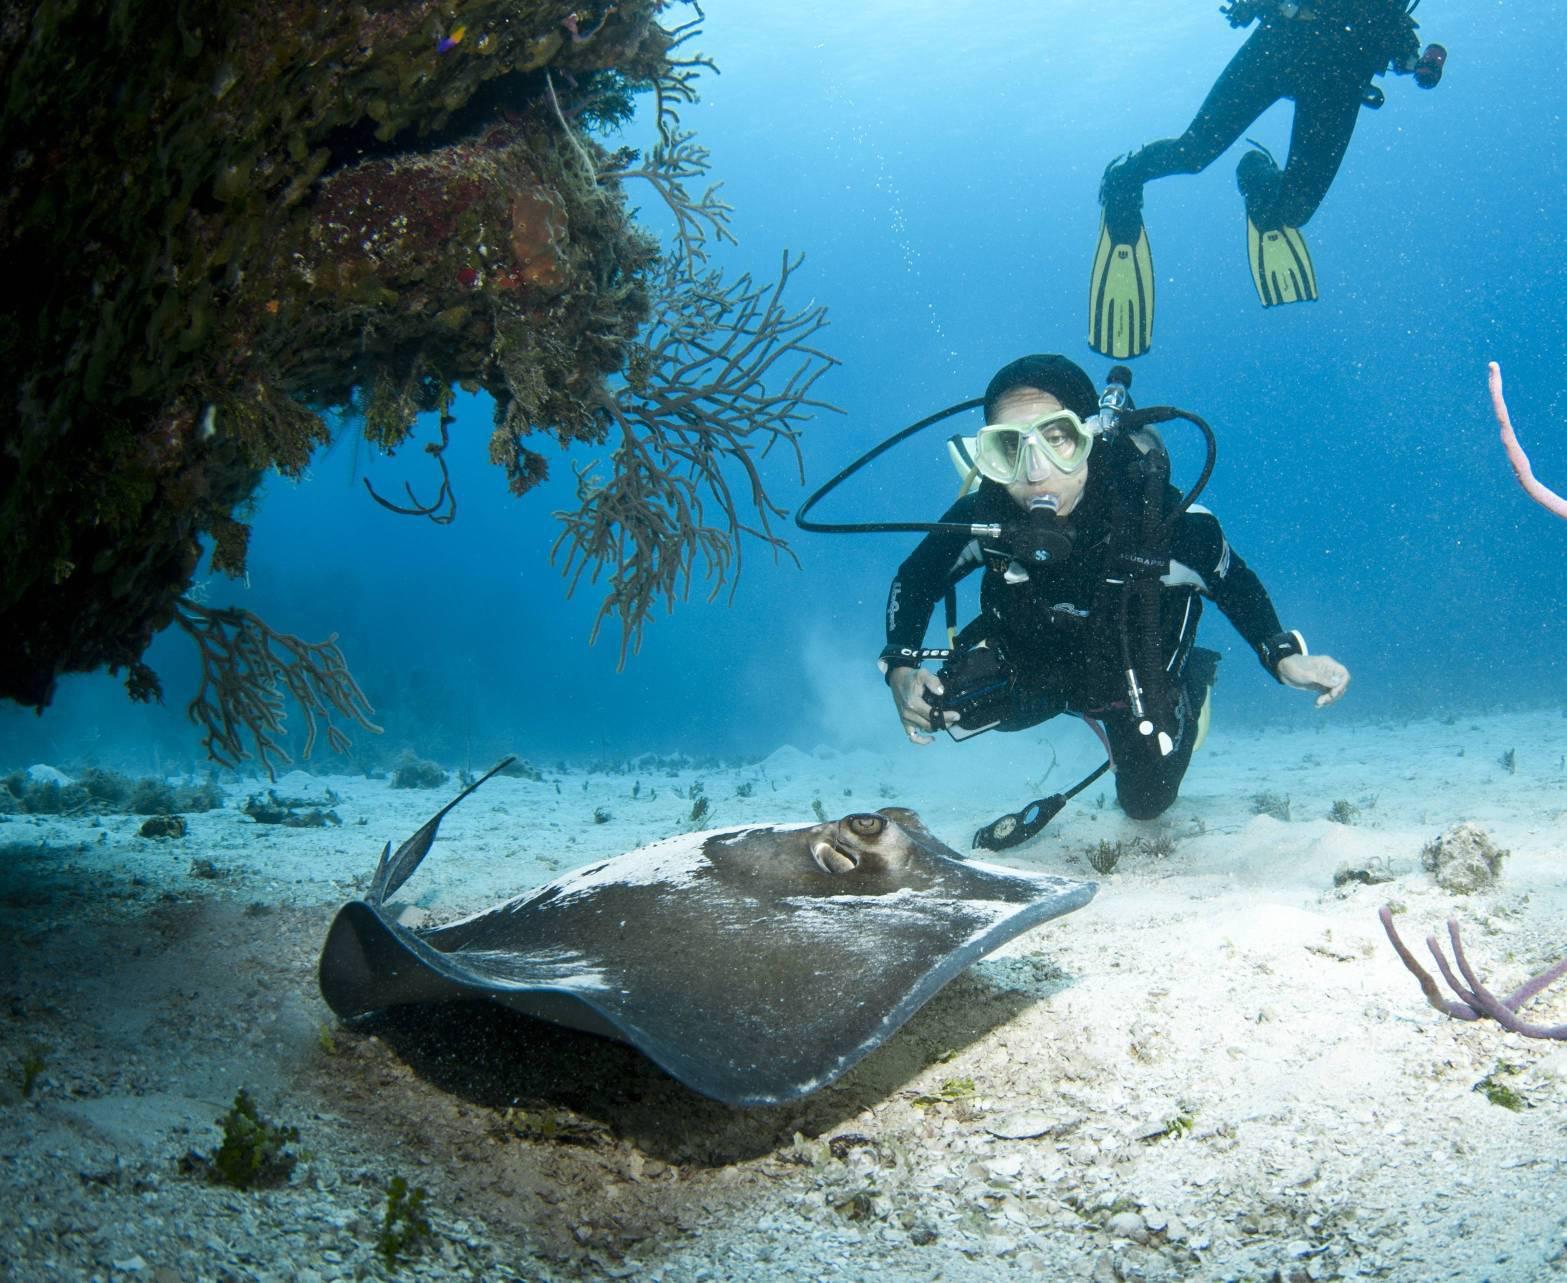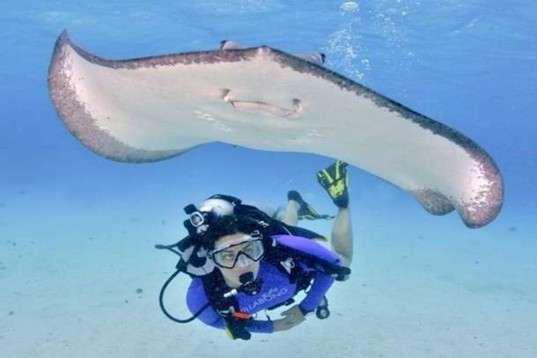The first image is the image on the left, the second image is the image on the right. Given the left and right images, does the statement "There is at least one image of a sting ray over the sand that is in front of a diver who is swimming." hold true? Answer yes or no. Yes. The first image is the image on the left, the second image is the image on the right. For the images displayed, is the sentence "There are exactly two scuba divers." factually correct? Answer yes or no. No. 